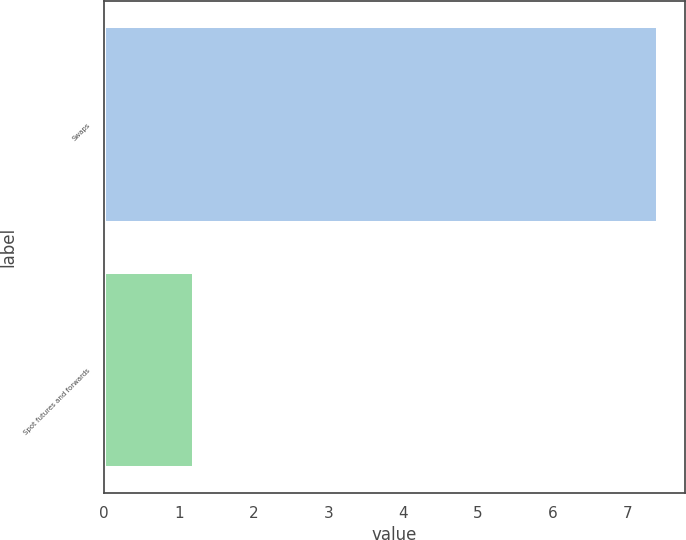Convert chart. <chart><loc_0><loc_0><loc_500><loc_500><bar_chart><fcel>Swaps<fcel>Spot futures and forwards<nl><fcel>7.4<fcel>1.2<nl></chart> 